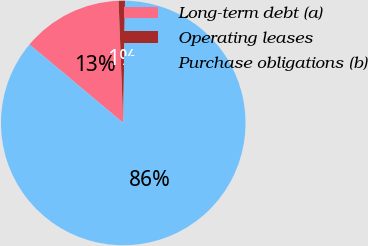Convert chart to OTSL. <chart><loc_0><loc_0><loc_500><loc_500><pie_chart><fcel>Long-term debt (a)<fcel>Operating leases<fcel>Purchase obligations (b)<nl><fcel>13.29%<fcel>0.84%<fcel>85.86%<nl></chart> 